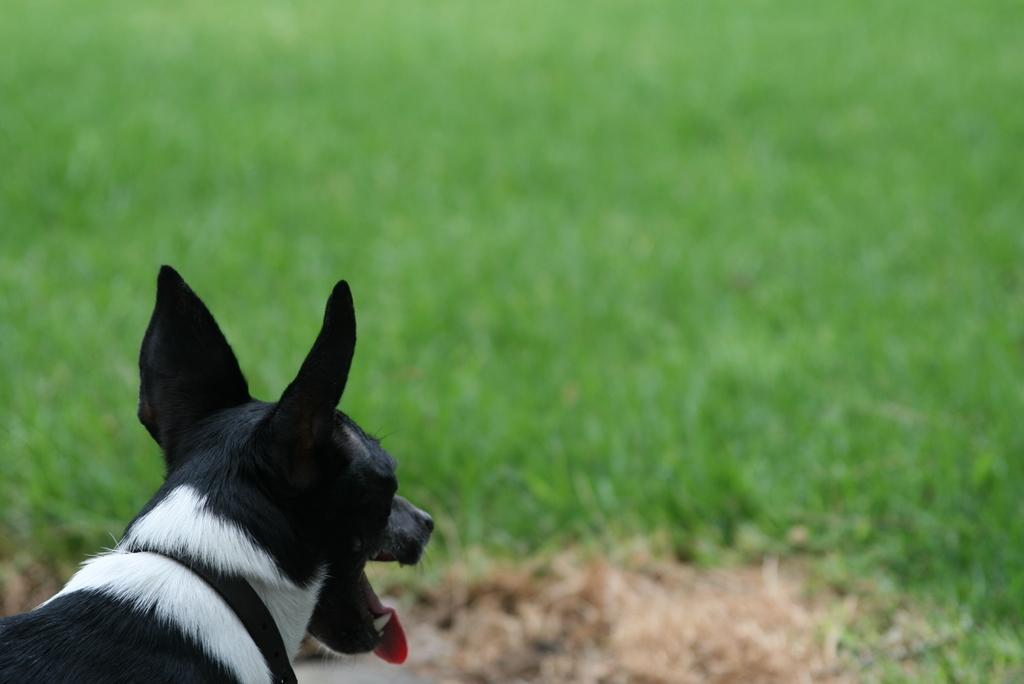What type of animal is in the image? There is a dog in the image. What colors can be seen on the dog? The dog is black and white in color. Can you describe the background of the image? The background of the image is blurred. How many horses are participating in the event in the image? There are no horses or events present in the image; it features a black and white dog with a blurred background. 